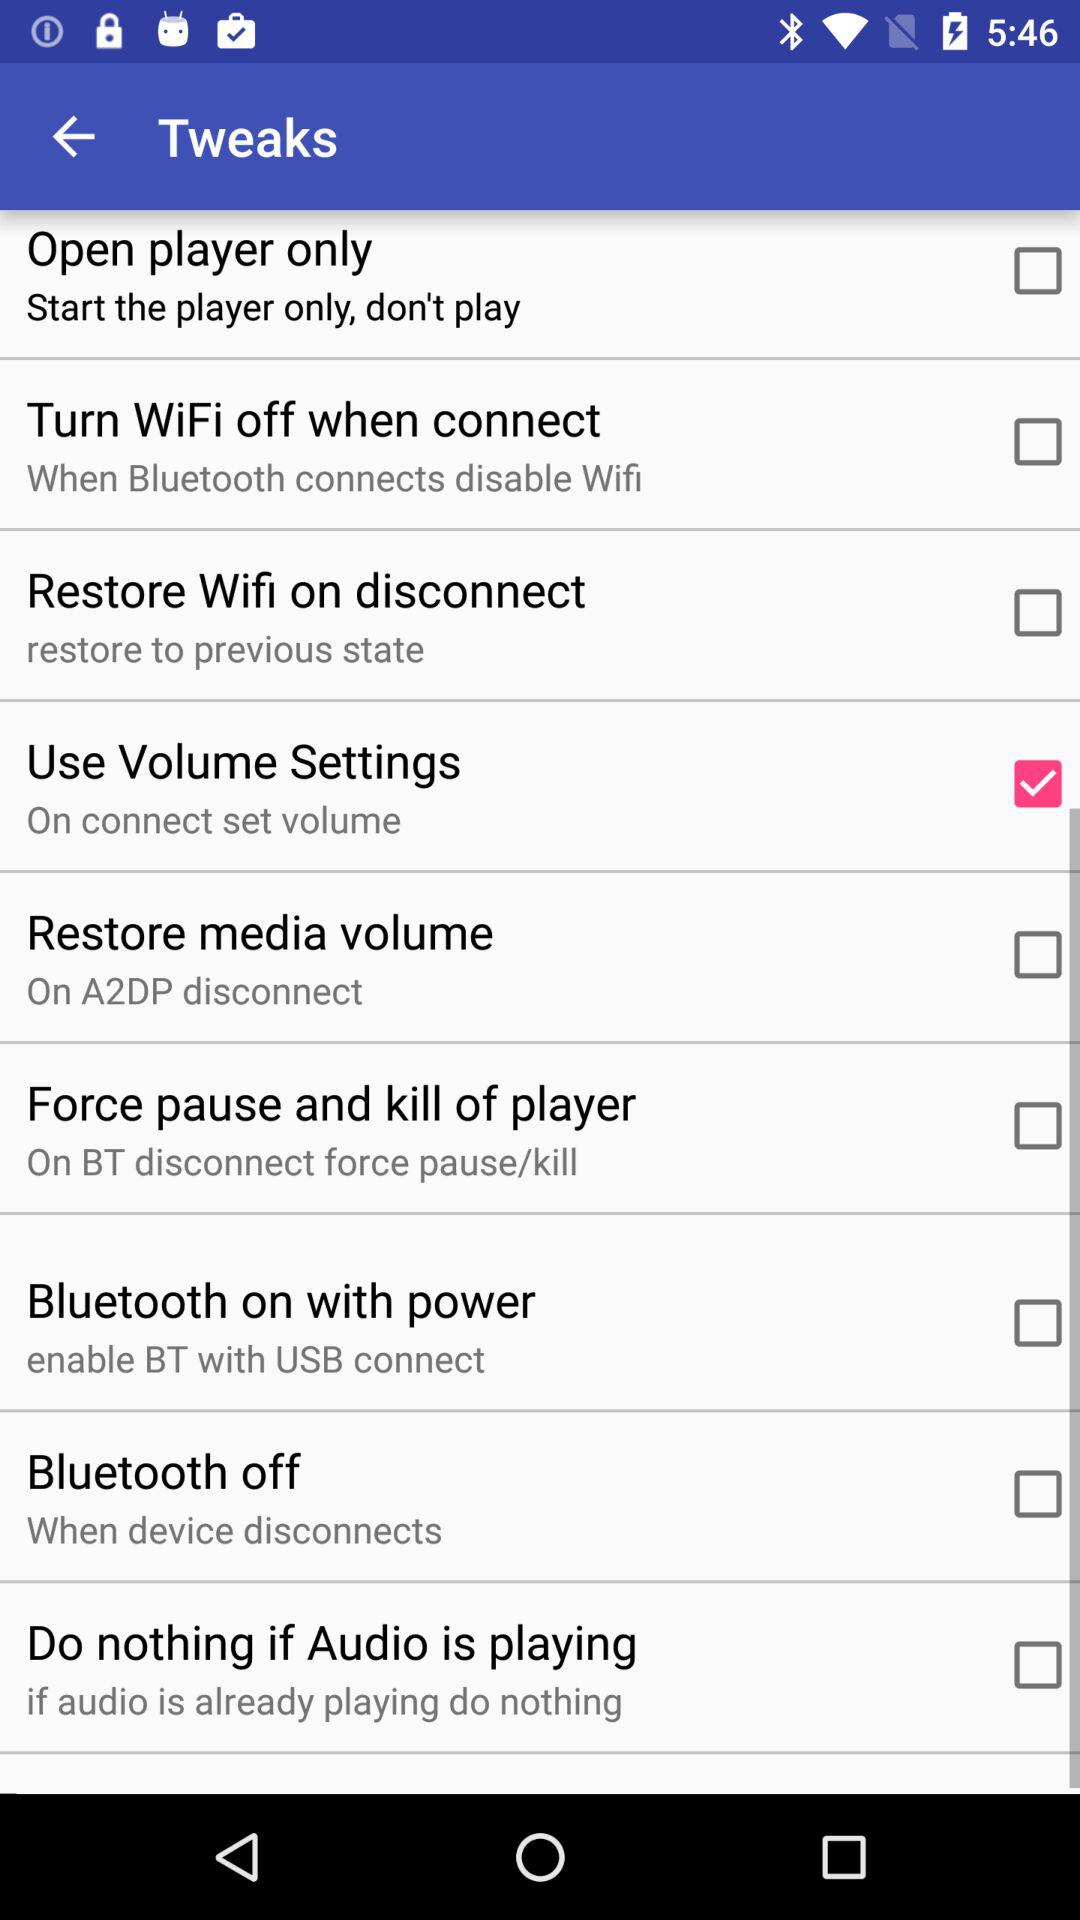What is the current status of the "Bluetooth on with power"? The status is "off". 